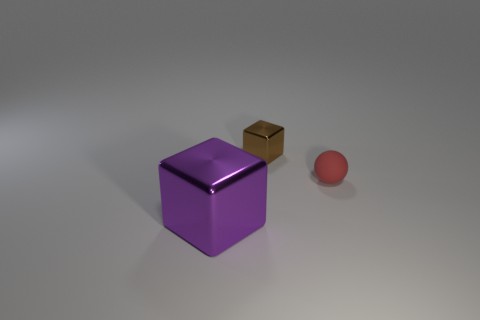Could these objects belong to some sort of game or activity? The objects don't bear distinct markings or features that categorically tie them to a specific game, but their shapes – a cube and a sphere – are common in many games. It's plausible that the sphere could be used in a variety of ball games, and the cubes might be used as dice in board games, given appropriate scaling. 